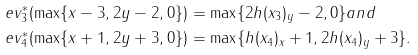<formula> <loc_0><loc_0><loc_500><loc_500>\ e v _ { 3 } ^ { \ast } ( \max \{ x - 3 , 2 y - 2 , 0 \} ) & = \max \{ 2 h ( x _ { 3 } ) _ { y } - 2 , 0 \} a n d \\ \ e v _ { 4 } ^ { \ast } ( \max \{ x + 1 , 2 y + 3 , 0 \} ) & = \max \{ h ( x _ { 4 } ) _ { x } + 1 , 2 h ( x _ { 4 } ) _ { y } + 3 \} .</formula> 